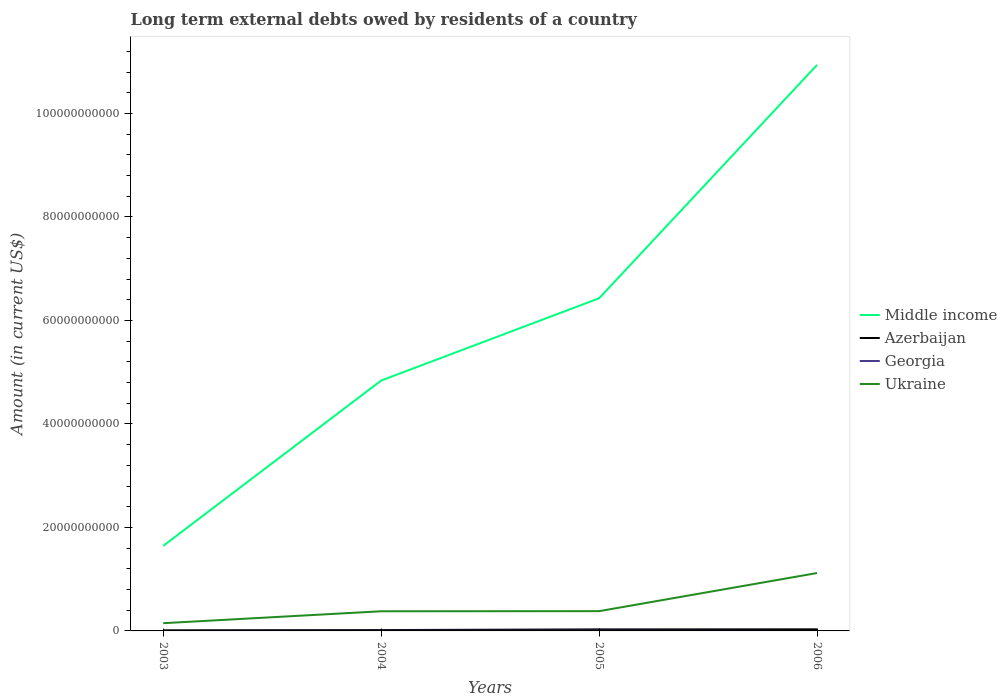How many different coloured lines are there?
Your answer should be very brief. 4. Does the line corresponding to Georgia intersect with the line corresponding to Ukraine?
Provide a short and direct response. No. Is the number of lines equal to the number of legend labels?
Your answer should be very brief. No. What is the total amount of long-term external debts owed by residents in Middle income in the graph?
Your response must be concise. -1.59e+1. What is the difference between the highest and the second highest amount of long-term external debts owed by residents in Ukraine?
Provide a short and direct response. 9.69e+09. What is the difference between the highest and the lowest amount of long-term external debts owed by residents in Middle income?
Keep it short and to the point. 2. Is the amount of long-term external debts owed by residents in Middle income strictly greater than the amount of long-term external debts owed by residents in Azerbaijan over the years?
Make the answer very short. No. How many lines are there?
Offer a terse response. 4. How many years are there in the graph?
Offer a terse response. 4. What is the difference between two consecutive major ticks on the Y-axis?
Make the answer very short. 2.00e+1. Does the graph contain any zero values?
Offer a very short reply. Yes. Where does the legend appear in the graph?
Keep it short and to the point. Center right. How many legend labels are there?
Provide a succinct answer. 4. What is the title of the graph?
Your answer should be very brief. Long term external debts owed by residents of a country. Does "Lesotho" appear as one of the legend labels in the graph?
Your answer should be compact. No. What is the label or title of the X-axis?
Your response must be concise. Years. What is the label or title of the Y-axis?
Your response must be concise. Amount (in current US$). What is the Amount (in current US$) of Middle income in 2003?
Make the answer very short. 1.64e+1. What is the Amount (in current US$) in Azerbaijan in 2003?
Ensure brevity in your answer.  1.18e+08. What is the Amount (in current US$) in Georgia in 2003?
Make the answer very short. 0. What is the Amount (in current US$) in Ukraine in 2003?
Provide a succinct answer. 1.49e+09. What is the Amount (in current US$) in Middle income in 2004?
Make the answer very short. 4.84e+1. What is the Amount (in current US$) of Azerbaijan in 2004?
Your response must be concise. 1.67e+08. What is the Amount (in current US$) in Georgia in 2004?
Provide a short and direct response. 3.23e+07. What is the Amount (in current US$) in Ukraine in 2004?
Give a very brief answer. 3.80e+09. What is the Amount (in current US$) of Middle income in 2005?
Your answer should be very brief. 6.43e+1. What is the Amount (in current US$) of Azerbaijan in 2005?
Make the answer very short. 2.97e+08. What is the Amount (in current US$) of Georgia in 2005?
Provide a succinct answer. 4.28e+07. What is the Amount (in current US$) in Ukraine in 2005?
Make the answer very short. 3.82e+09. What is the Amount (in current US$) in Middle income in 2006?
Offer a very short reply. 1.09e+11. What is the Amount (in current US$) in Azerbaijan in 2006?
Your answer should be compact. 3.07e+08. What is the Amount (in current US$) of Ukraine in 2006?
Offer a very short reply. 1.12e+1. Across all years, what is the maximum Amount (in current US$) in Middle income?
Provide a short and direct response. 1.09e+11. Across all years, what is the maximum Amount (in current US$) in Azerbaijan?
Offer a terse response. 3.07e+08. Across all years, what is the maximum Amount (in current US$) in Georgia?
Your answer should be compact. 4.28e+07. Across all years, what is the maximum Amount (in current US$) of Ukraine?
Offer a terse response. 1.12e+1. Across all years, what is the minimum Amount (in current US$) in Middle income?
Make the answer very short. 1.64e+1. Across all years, what is the minimum Amount (in current US$) in Azerbaijan?
Provide a short and direct response. 1.18e+08. Across all years, what is the minimum Amount (in current US$) of Georgia?
Offer a terse response. 0. Across all years, what is the minimum Amount (in current US$) in Ukraine?
Your answer should be compact. 1.49e+09. What is the total Amount (in current US$) in Middle income in the graph?
Offer a terse response. 2.38e+11. What is the total Amount (in current US$) of Azerbaijan in the graph?
Ensure brevity in your answer.  8.89e+08. What is the total Amount (in current US$) in Georgia in the graph?
Keep it short and to the point. 7.50e+07. What is the total Amount (in current US$) of Ukraine in the graph?
Your answer should be compact. 2.03e+1. What is the difference between the Amount (in current US$) in Middle income in 2003 and that in 2004?
Give a very brief answer. -3.19e+1. What is the difference between the Amount (in current US$) of Azerbaijan in 2003 and that in 2004?
Offer a very short reply. -4.94e+07. What is the difference between the Amount (in current US$) of Ukraine in 2003 and that in 2004?
Offer a very short reply. -2.30e+09. What is the difference between the Amount (in current US$) of Middle income in 2003 and that in 2005?
Ensure brevity in your answer.  -4.78e+1. What is the difference between the Amount (in current US$) of Azerbaijan in 2003 and that in 2005?
Make the answer very short. -1.79e+08. What is the difference between the Amount (in current US$) of Ukraine in 2003 and that in 2005?
Offer a terse response. -2.33e+09. What is the difference between the Amount (in current US$) of Middle income in 2003 and that in 2006?
Offer a terse response. -9.29e+1. What is the difference between the Amount (in current US$) of Azerbaijan in 2003 and that in 2006?
Keep it short and to the point. -1.89e+08. What is the difference between the Amount (in current US$) in Ukraine in 2003 and that in 2006?
Ensure brevity in your answer.  -9.69e+09. What is the difference between the Amount (in current US$) of Middle income in 2004 and that in 2005?
Your response must be concise. -1.59e+1. What is the difference between the Amount (in current US$) in Azerbaijan in 2004 and that in 2005?
Offer a very short reply. -1.30e+08. What is the difference between the Amount (in current US$) of Georgia in 2004 and that in 2005?
Make the answer very short. -1.05e+07. What is the difference between the Amount (in current US$) in Ukraine in 2004 and that in 2005?
Ensure brevity in your answer.  -2.22e+07. What is the difference between the Amount (in current US$) of Middle income in 2004 and that in 2006?
Make the answer very short. -6.10e+1. What is the difference between the Amount (in current US$) in Azerbaijan in 2004 and that in 2006?
Offer a terse response. -1.40e+08. What is the difference between the Amount (in current US$) of Ukraine in 2004 and that in 2006?
Provide a short and direct response. -7.39e+09. What is the difference between the Amount (in current US$) in Middle income in 2005 and that in 2006?
Give a very brief answer. -4.51e+1. What is the difference between the Amount (in current US$) in Azerbaijan in 2005 and that in 2006?
Provide a succinct answer. -1.00e+07. What is the difference between the Amount (in current US$) in Ukraine in 2005 and that in 2006?
Make the answer very short. -7.37e+09. What is the difference between the Amount (in current US$) of Middle income in 2003 and the Amount (in current US$) of Azerbaijan in 2004?
Offer a terse response. 1.63e+1. What is the difference between the Amount (in current US$) in Middle income in 2003 and the Amount (in current US$) in Georgia in 2004?
Ensure brevity in your answer.  1.64e+1. What is the difference between the Amount (in current US$) in Middle income in 2003 and the Amount (in current US$) in Ukraine in 2004?
Offer a terse response. 1.26e+1. What is the difference between the Amount (in current US$) of Azerbaijan in 2003 and the Amount (in current US$) of Georgia in 2004?
Keep it short and to the point. 8.54e+07. What is the difference between the Amount (in current US$) in Azerbaijan in 2003 and the Amount (in current US$) in Ukraine in 2004?
Make the answer very short. -3.68e+09. What is the difference between the Amount (in current US$) of Middle income in 2003 and the Amount (in current US$) of Azerbaijan in 2005?
Provide a succinct answer. 1.61e+1. What is the difference between the Amount (in current US$) of Middle income in 2003 and the Amount (in current US$) of Georgia in 2005?
Give a very brief answer. 1.64e+1. What is the difference between the Amount (in current US$) in Middle income in 2003 and the Amount (in current US$) in Ukraine in 2005?
Keep it short and to the point. 1.26e+1. What is the difference between the Amount (in current US$) of Azerbaijan in 2003 and the Amount (in current US$) of Georgia in 2005?
Your answer should be very brief. 7.49e+07. What is the difference between the Amount (in current US$) in Azerbaijan in 2003 and the Amount (in current US$) in Ukraine in 2005?
Your answer should be very brief. -3.70e+09. What is the difference between the Amount (in current US$) of Middle income in 2003 and the Amount (in current US$) of Azerbaijan in 2006?
Your answer should be compact. 1.61e+1. What is the difference between the Amount (in current US$) in Middle income in 2003 and the Amount (in current US$) in Ukraine in 2006?
Ensure brevity in your answer.  5.25e+09. What is the difference between the Amount (in current US$) in Azerbaijan in 2003 and the Amount (in current US$) in Ukraine in 2006?
Give a very brief answer. -1.11e+1. What is the difference between the Amount (in current US$) in Middle income in 2004 and the Amount (in current US$) in Azerbaijan in 2005?
Your answer should be compact. 4.81e+1. What is the difference between the Amount (in current US$) in Middle income in 2004 and the Amount (in current US$) in Georgia in 2005?
Provide a succinct answer. 4.83e+1. What is the difference between the Amount (in current US$) in Middle income in 2004 and the Amount (in current US$) in Ukraine in 2005?
Your answer should be very brief. 4.46e+1. What is the difference between the Amount (in current US$) of Azerbaijan in 2004 and the Amount (in current US$) of Georgia in 2005?
Your response must be concise. 1.24e+08. What is the difference between the Amount (in current US$) in Azerbaijan in 2004 and the Amount (in current US$) in Ukraine in 2005?
Your answer should be very brief. -3.65e+09. What is the difference between the Amount (in current US$) of Georgia in 2004 and the Amount (in current US$) of Ukraine in 2005?
Your answer should be very brief. -3.79e+09. What is the difference between the Amount (in current US$) in Middle income in 2004 and the Amount (in current US$) in Azerbaijan in 2006?
Offer a very short reply. 4.81e+1. What is the difference between the Amount (in current US$) of Middle income in 2004 and the Amount (in current US$) of Ukraine in 2006?
Ensure brevity in your answer.  3.72e+1. What is the difference between the Amount (in current US$) of Azerbaijan in 2004 and the Amount (in current US$) of Ukraine in 2006?
Provide a short and direct response. -1.10e+1. What is the difference between the Amount (in current US$) in Georgia in 2004 and the Amount (in current US$) in Ukraine in 2006?
Provide a succinct answer. -1.12e+1. What is the difference between the Amount (in current US$) in Middle income in 2005 and the Amount (in current US$) in Azerbaijan in 2006?
Ensure brevity in your answer.  6.40e+1. What is the difference between the Amount (in current US$) of Middle income in 2005 and the Amount (in current US$) of Ukraine in 2006?
Keep it short and to the point. 5.31e+1. What is the difference between the Amount (in current US$) of Azerbaijan in 2005 and the Amount (in current US$) of Ukraine in 2006?
Give a very brief answer. -1.09e+1. What is the difference between the Amount (in current US$) in Georgia in 2005 and the Amount (in current US$) in Ukraine in 2006?
Offer a terse response. -1.11e+1. What is the average Amount (in current US$) of Middle income per year?
Provide a succinct answer. 5.96e+1. What is the average Amount (in current US$) in Azerbaijan per year?
Provide a short and direct response. 2.22e+08. What is the average Amount (in current US$) in Georgia per year?
Keep it short and to the point. 1.88e+07. What is the average Amount (in current US$) in Ukraine per year?
Your answer should be compact. 5.07e+09. In the year 2003, what is the difference between the Amount (in current US$) of Middle income and Amount (in current US$) of Azerbaijan?
Offer a terse response. 1.63e+1. In the year 2003, what is the difference between the Amount (in current US$) of Middle income and Amount (in current US$) of Ukraine?
Give a very brief answer. 1.49e+1. In the year 2003, what is the difference between the Amount (in current US$) of Azerbaijan and Amount (in current US$) of Ukraine?
Offer a terse response. -1.38e+09. In the year 2004, what is the difference between the Amount (in current US$) in Middle income and Amount (in current US$) in Azerbaijan?
Your response must be concise. 4.82e+1. In the year 2004, what is the difference between the Amount (in current US$) in Middle income and Amount (in current US$) in Georgia?
Offer a terse response. 4.84e+1. In the year 2004, what is the difference between the Amount (in current US$) in Middle income and Amount (in current US$) in Ukraine?
Make the answer very short. 4.46e+1. In the year 2004, what is the difference between the Amount (in current US$) in Azerbaijan and Amount (in current US$) in Georgia?
Make the answer very short. 1.35e+08. In the year 2004, what is the difference between the Amount (in current US$) in Azerbaijan and Amount (in current US$) in Ukraine?
Keep it short and to the point. -3.63e+09. In the year 2004, what is the difference between the Amount (in current US$) of Georgia and Amount (in current US$) of Ukraine?
Ensure brevity in your answer.  -3.77e+09. In the year 2005, what is the difference between the Amount (in current US$) in Middle income and Amount (in current US$) in Azerbaijan?
Offer a very short reply. 6.40e+1. In the year 2005, what is the difference between the Amount (in current US$) of Middle income and Amount (in current US$) of Georgia?
Provide a short and direct response. 6.42e+1. In the year 2005, what is the difference between the Amount (in current US$) of Middle income and Amount (in current US$) of Ukraine?
Give a very brief answer. 6.05e+1. In the year 2005, what is the difference between the Amount (in current US$) in Azerbaijan and Amount (in current US$) in Georgia?
Ensure brevity in your answer.  2.54e+08. In the year 2005, what is the difference between the Amount (in current US$) in Azerbaijan and Amount (in current US$) in Ukraine?
Your answer should be compact. -3.52e+09. In the year 2005, what is the difference between the Amount (in current US$) in Georgia and Amount (in current US$) in Ukraine?
Provide a succinct answer. -3.78e+09. In the year 2006, what is the difference between the Amount (in current US$) in Middle income and Amount (in current US$) in Azerbaijan?
Your answer should be very brief. 1.09e+11. In the year 2006, what is the difference between the Amount (in current US$) in Middle income and Amount (in current US$) in Ukraine?
Your response must be concise. 9.82e+1. In the year 2006, what is the difference between the Amount (in current US$) of Azerbaijan and Amount (in current US$) of Ukraine?
Your response must be concise. -1.09e+1. What is the ratio of the Amount (in current US$) in Middle income in 2003 to that in 2004?
Provide a short and direct response. 0.34. What is the ratio of the Amount (in current US$) in Azerbaijan in 2003 to that in 2004?
Give a very brief answer. 0.7. What is the ratio of the Amount (in current US$) of Ukraine in 2003 to that in 2004?
Your answer should be compact. 0.39. What is the ratio of the Amount (in current US$) of Middle income in 2003 to that in 2005?
Provide a short and direct response. 0.26. What is the ratio of the Amount (in current US$) in Azerbaijan in 2003 to that in 2005?
Ensure brevity in your answer.  0.4. What is the ratio of the Amount (in current US$) in Ukraine in 2003 to that in 2005?
Provide a short and direct response. 0.39. What is the ratio of the Amount (in current US$) of Middle income in 2003 to that in 2006?
Offer a very short reply. 0.15. What is the ratio of the Amount (in current US$) of Azerbaijan in 2003 to that in 2006?
Provide a short and direct response. 0.38. What is the ratio of the Amount (in current US$) of Ukraine in 2003 to that in 2006?
Your answer should be compact. 0.13. What is the ratio of the Amount (in current US$) of Middle income in 2004 to that in 2005?
Provide a succinct answer. 0.75. What is the ratio of the Amount (in current US$) in Azerbaijan in 2004 to that in 2005?
Your answer should be very brief. 0.56. What is the ratio of the Amount (in current US$) in Georgia in 2004 to that in 2005?
Make the answer very short. 0.75. What is the ratio of the Amount (in current US$) of Middle income in 2004 to that in 2006?
Make the answer very short. 0.44. What is the ratio of the Amount (in current US$) in Azerbaijan in 2004 to that in 2006?
Offer a terse response. 0.54. What is the ratio of the Amount (in current US$) in Ukraine in 2004 to that in 2006?
Offer a terse response. 0.34. What is the ratio of the Amount (in current US$) in Middle income in 2005 to that in 2006?
Keep it short and to the point. 0.59. What is the ratio of the Amount (in current US$) in Azerbaijan in 2005 to that in 2006?
Provide a short and direct response. 0.97. What is the ratio of the Amount (in current US$) of Ukraine in 2005 to that in 2006?
Your answer should be compact. 0.34. What is the difference between the highest and the second highest Amount (in current US$) of Middle income?
Your answer should be very brief. 4.51e+1. What is the difference between the highest and the second highest Amount (in current US$) of Azerbaijan?
Your answer should be very brief. 1.00e+07. What is the difference between the highest and the second highest Amount (in current US$) of Ukraine?
Provide a short and direct response. 7.37e+09. What is the difference between the highest and the lowest Amount (in current US$) of Middle income?
Make the answer very short. 9.29e+1. What is the difference between the highest and the lowest Amount (in current US$) in Azerbaijan?
Provide a short and direct response. 1.89e+08. What is the difference between the highest and the lowest Amount (in current US$) of Georgia?
Provide a short and direct response. 4.28e+07. What is the difference between the highest and the lowest Amount (in current US$) in Ukraine?
Provide a succinct answer. 9.69e+09. 